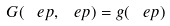Convert formula to latex. <formula><loc_0><loc_0><loc_500><loc_500>G ( \ e p , \ e p ) = g ( \ e p )</formula> 